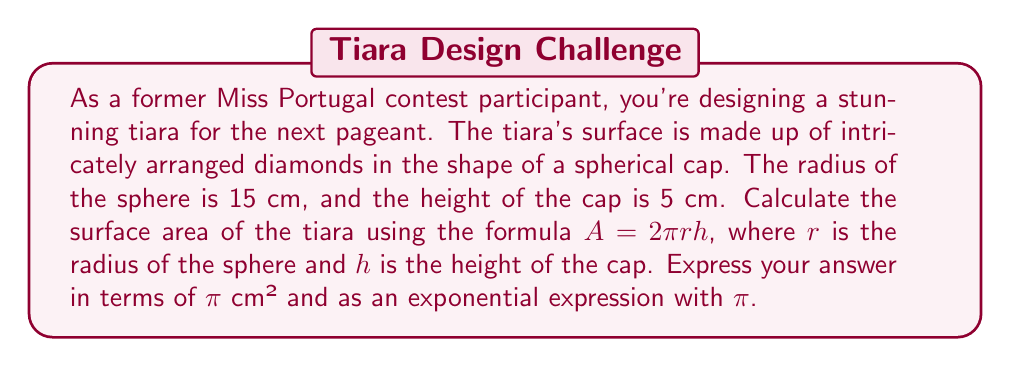Can you answer this question? Let's approach this step-by-step:

1) We are given the formula for the surface area of a spherical cap:
   $A = 2\pi rh$

2) We know:
   $r = 15$ cm (radius of the sphere)
   $h = 5$ cm (height of the cap)

3) Let's substitute these values into the formula:
   $A = 2\pi \cdot 15 \cdot 5$

4) Simplify:
   $A = 2\pi \cdot 75$
   $A = 150\pi$

5) To express this as an exponential with $\pi$:
   $A = 150\pi = (10^2 \cdot 1.5)\pi = 1.5 \cdot 10^2 \pi$

Therefore, the surface area of the tiara is $150\pi$ cm² or $1.5 \cdot 10^2 \pi$ cm².
Answer: $150\pi$ cm² or $1.5 \cdot 10^2 \pi$ cm² 